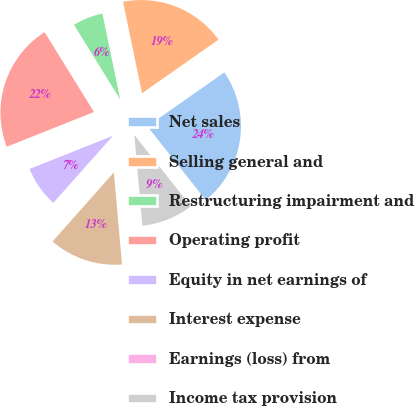Convert chart to OTSL. <chart><loc_0><loc_0><loc_500><loc_500><pie_chart><fcel>Net sales<fcel>Selling general and<fcel>Restructuring impairment and<fcel>Operating profit<fcel>Equity in net earnings of<fcel>Interest expense<fcel>Earnings (loss) from<fcel>Income tax provision<nl><fcel>24.07%<fcel>18.52%<fcel>5.56%<fcel>22.22%<fcel>7.41%<fcel>12.96%<fcel>0.0%<fcel>9.26%<nl></chart> 